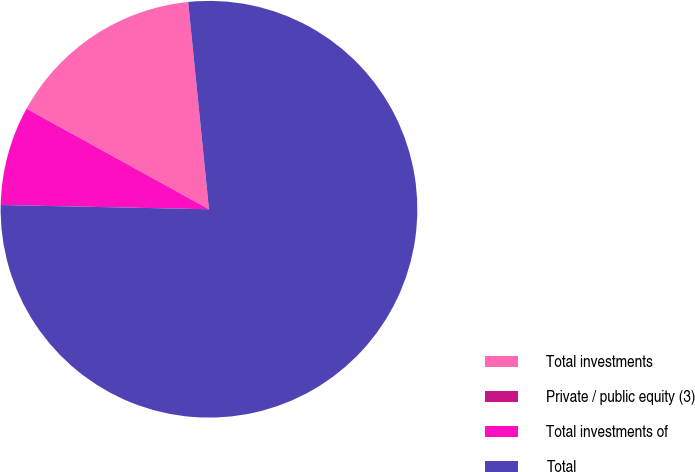Convert chart to OTSL. <chart><loc_0><loc_0><loc_500><loc_500><pie_chart><fcel>Total investments<fcel>Private / public equity (3)<fcel>Total investments of<fcel>Total<nl><fcel>15.39%<fcel>0.0%<fcel>7.69%<fcel>76.92%<nl></chart> 